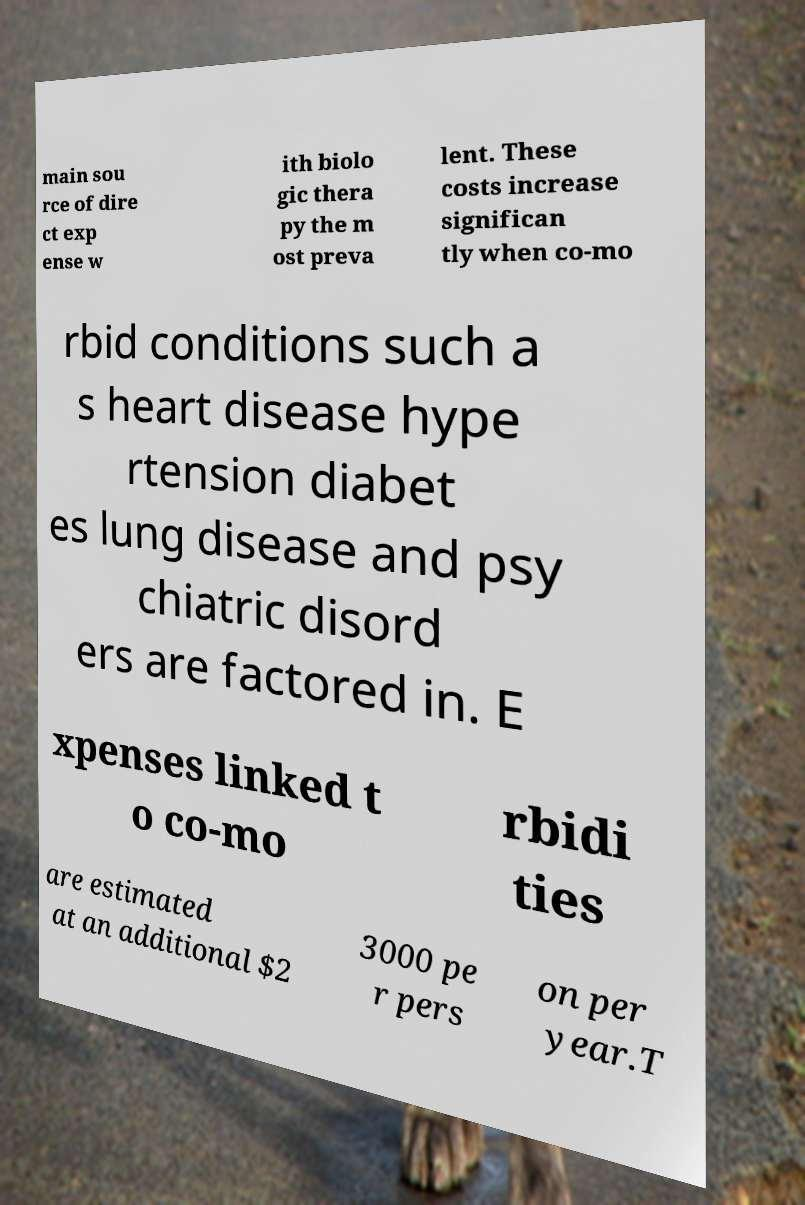Could you extract and type out the text from this image? main sou rce of dire ct exp ense w ith biolo gic thera py the m ost preva lent. These costs increase significan tly when co-mo rbid conditions such a s heart disease hype rtension diabet es lung disease and psy chiatric disord ers are factored in. E xpenses linked t o co-mo rbidi ties are estimated at an additional $2 3000 pe r pers on per year.T 